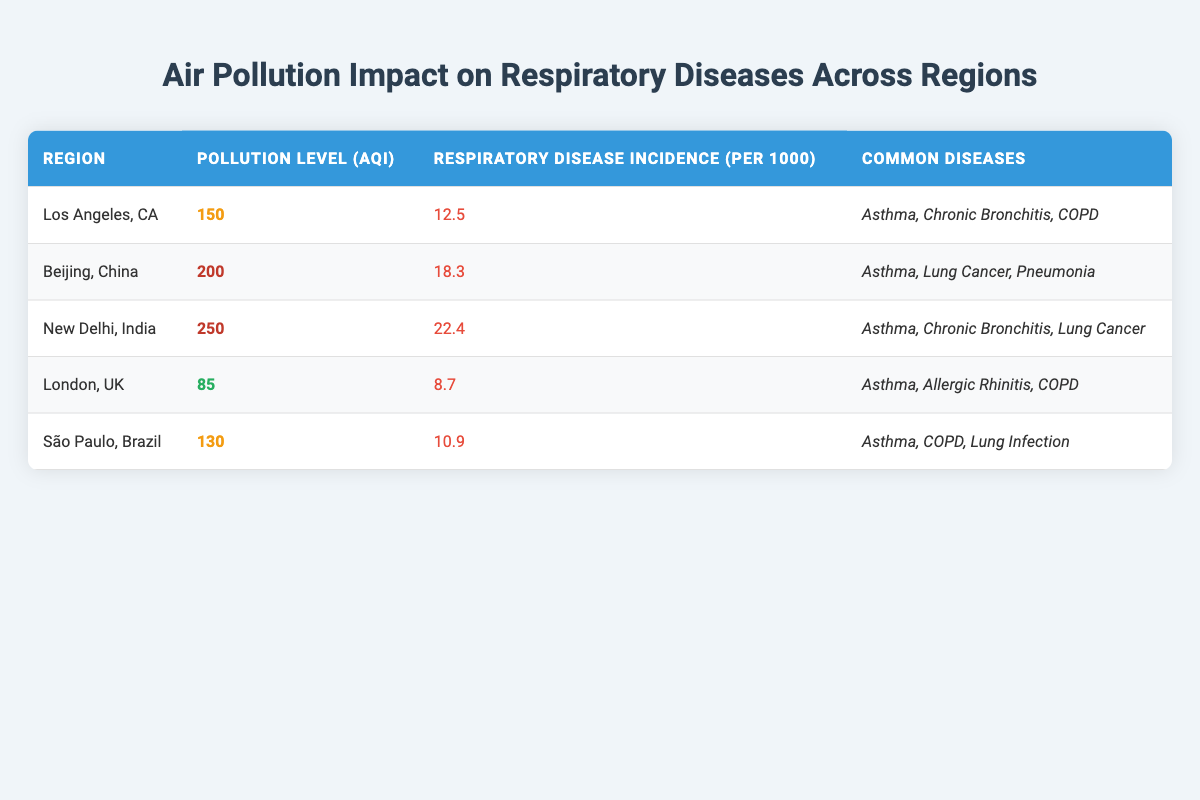What is the pollution level in New Delhi, India? The table indicates that the pollution level in New Delhi, India is 250 AQI.
Answer: 250 AQI Which region has the highest respiratory disease incidence? By looking at the "Respiratory Disease Incidence (per 1000)" column, New Delhi, India has the highest incidence with a value of 22.4.
Answer: New Delhi, India Are asthma and COPD common diseases in Los Angeles, CA? According to the table, both asthma and COPD are listed as common diseases in Los Angeles, CA.
Answer: Yes What is the average respiratory disease incidence across all regions? To calculate the average, we add all the incidences: (12.5 + 18.3 + 22.4 + 8.7 + 10.9) = 72.8. Then, we divide by the number of regions (5): 72.8 / 5 = 14.56.
Answer: 14.56 Is the pollution level in London, UK classified as high? The pollution level in London, UK is 85 AQI, which is categorized as low pollution according to the table.
Answer: No Which region has the lowest pollution level? The table shows that London, UK has the lowest pollution level at 85 AQI compared to the other regions.
Answer: London, UK What is the difference in respiratory disease incidence between Beijing, China, and São Paulo, Brazil? The incidence in Beijing is 18.3 and in São Paulo is 10.9, so the difference is 18.3 - 10.9 = 7.4.
Answer: 7.4 Are lung infections listed as a common disease in all the regions? The table indicates that lung infections are only mentioned as a common disease in São Paulo, Brazil, not in all regions.
Answer: No Which diseases are common in New Delhi, India? The table lists the common diseases in New Delhi, India as asthma, chronic bronchitis, and lung cancer.
Answer: Asthma, chronic bronchitis, lung cancer 